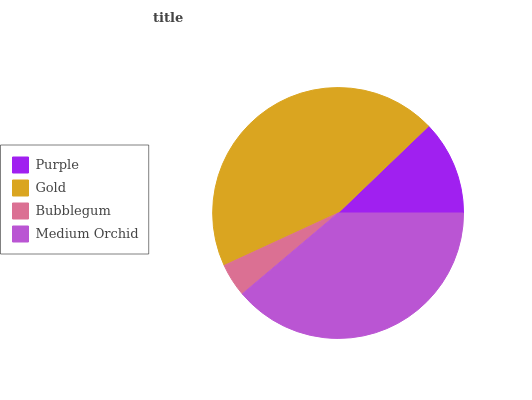Is Bubblegum the minimum?
Answer yes or no. Yes. Is Gold the maximum?
Answer yes or no. Yes. Is Gold the minimum?
Answer yes or no. No. Is Bubblegum the maximum?
Answer yes or no. No. Is Gold greater than Bubblegum?
Answer yes or no. Yes. Is Bubblegum less than Gold?
Answer yes or no. Yes. Is Bubblegum greater than Gold?
Answer yes or no. No. Is Gold less than Bubblegum?
Answer yes or no. No. Is Medium Orchid the high median?
Answer yes or no. Yes. Is Purple the low median?
Answer yes or no. Yes. Is Purple the high median?
Answer yes or no. No. Is Gold the low median?
Answer yes or no. No. 